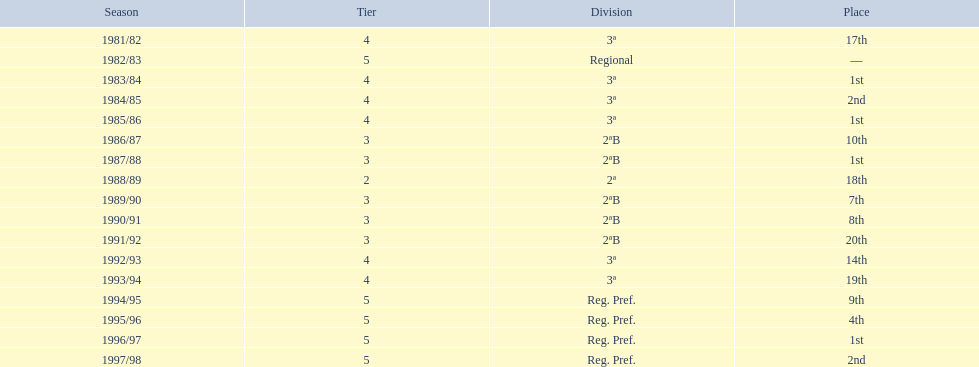What is the minimum position the team has achieved? 20th. In which year did they finish in 20th place? 1991/92. 